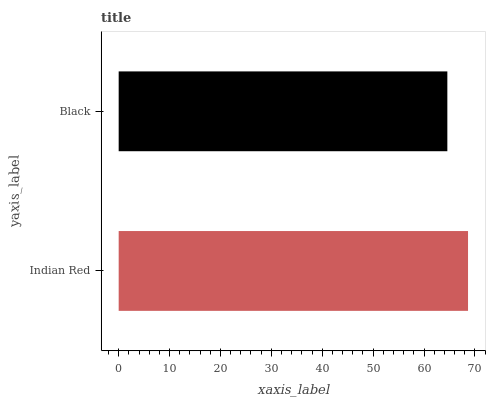Is Black the minimum?
Answer yes or no. Yes. Is Indian Red the maximum?
Answer yes or no. Yes. Is Black the maximum?
Answer yes or no. No. Is Indian Red greater than Black?
Answer yes or no. Yes. Is Black less than Indian Red?
Answer yes or no. Yes. Is Black greater than Indian Red?
Answer yes or no. No. Is Indian Red less than Black?
Answer yes or no. No. Is Indian Red the high median?
Answer yes or no. Yes. Is Black the low median?
Answer yes or no. Yes. Is Black the high median?
Answer yes or no. No. Is Indian Red the low median?
Answer yes or no. No. 